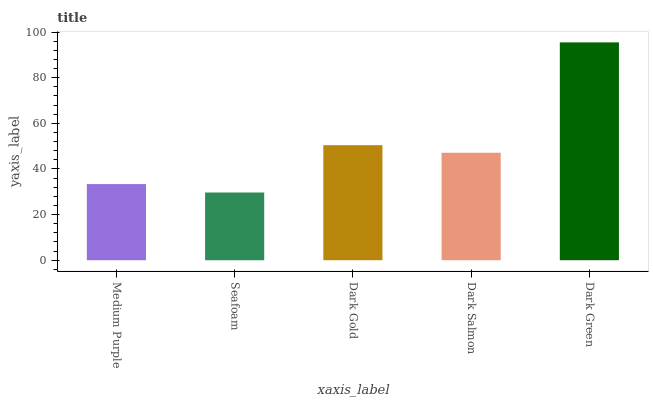Is Seafoam the minimum?
Answer yes or no. Yes. Is Dark Green the maximum?
Answer yes or no. Yes. Is Dark Gold the minimum?
Answer yes or no. No. Is Dark Gold the maximum?
Answer yes or no. No. Is Dark Gold greater than Seafoam?
Answer yes or no. Yes. Is Seafoam less than Dark Gold?
Answer yes or no. Yes. Is Seafoam greater than Dark Gold?
Answer yes or no. No. Is Dark Gold less than Seafoam?
Answer yes or no. No. Is Dark Salmon the high median?
Answer yes or no. Yes. Is Dark Salmon the low median?
Answer yes or no. Yes. Is Dark Gold the high median?
Answer yes or no. No. Is Seafoam the low median?
Answer yes or no. No. 